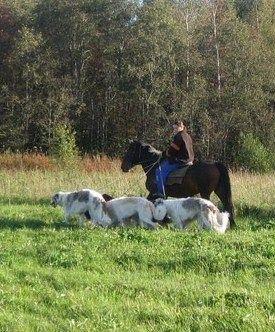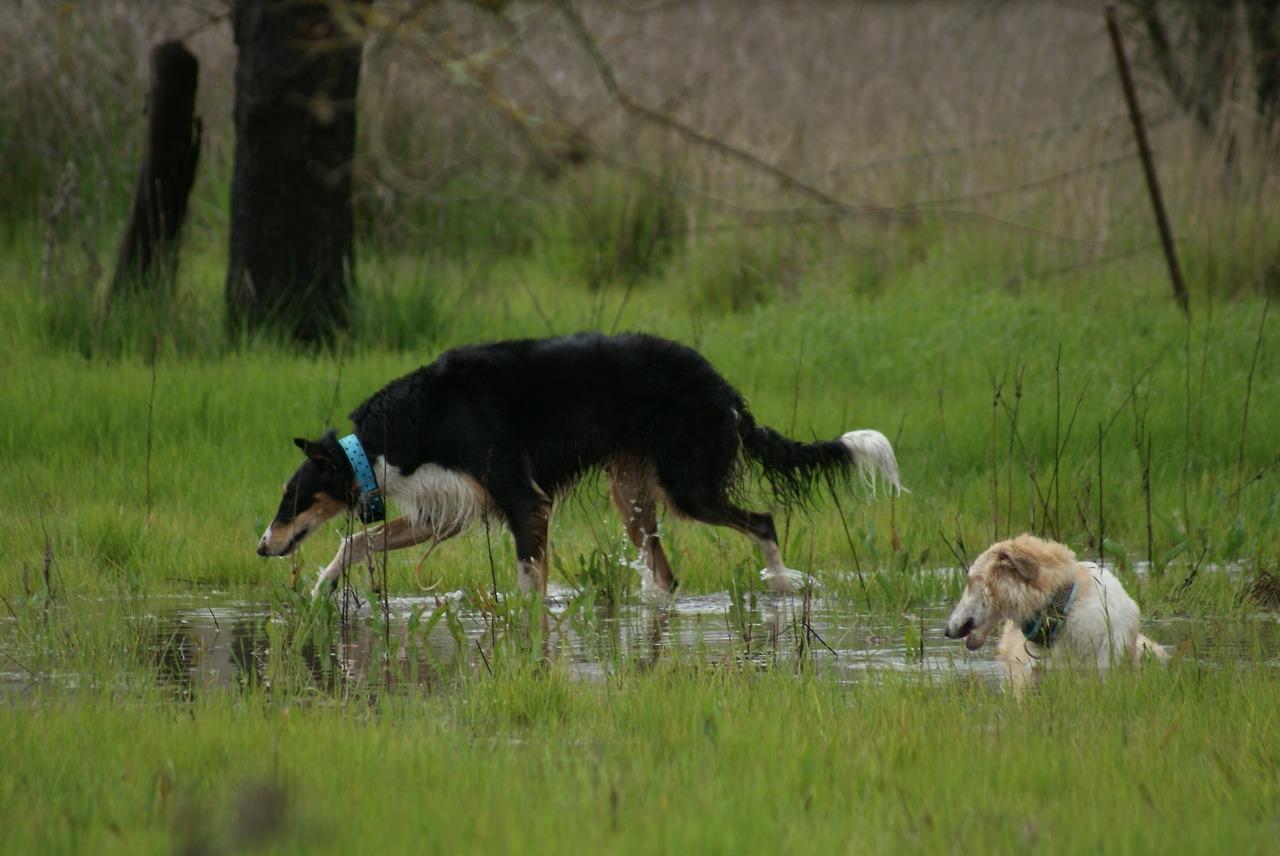The first image is the image on the left, the second image is the image on the right. Analyze the images presented: Is the assertion "Each image includes bounding hounds, and the right image shows a hound with its body leaning to the right as it runs forward." valid? Answer yes or no. No. The first image is the image on the left, the second image is the image on the right. Given the left and right images, does the statement "At least one dog has its front paws off the ground." hold true? Answer yes or no. No. 